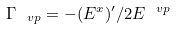Convert formula to latex. <formula><loc_0><loc_0><loc_500><loc_500>\Gamma _ { \ v p } = - ( E ^ { x } ) ^ { \prime } / 2 E ^ { \ v p }</formula> 